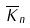Convert formula to latex. <formula><loc_0><loc_0><loc_500><loc_500>\overline { K } _ { n }</formula> 